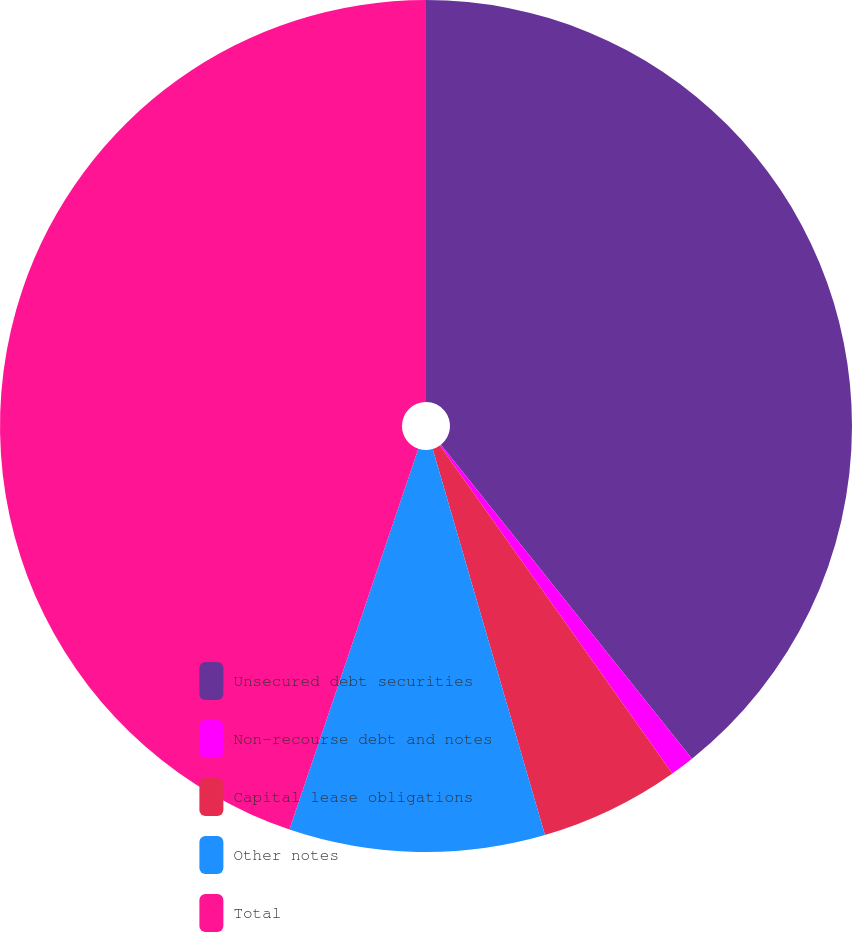Convert chart. <chart><loc_0><loc_0><loc_500><loc_500><pie_chart><fcel>Unsecured debt securities<fcel>Non-recourse debt and notes<fcel>Capital lease obligations<fcel>Other notes<fcel>Total<nl><fcel>39.27%<fcel>0.92%<fcel>5.31%<fcel>9.7%<fcel>44.81%<nl></chart> 